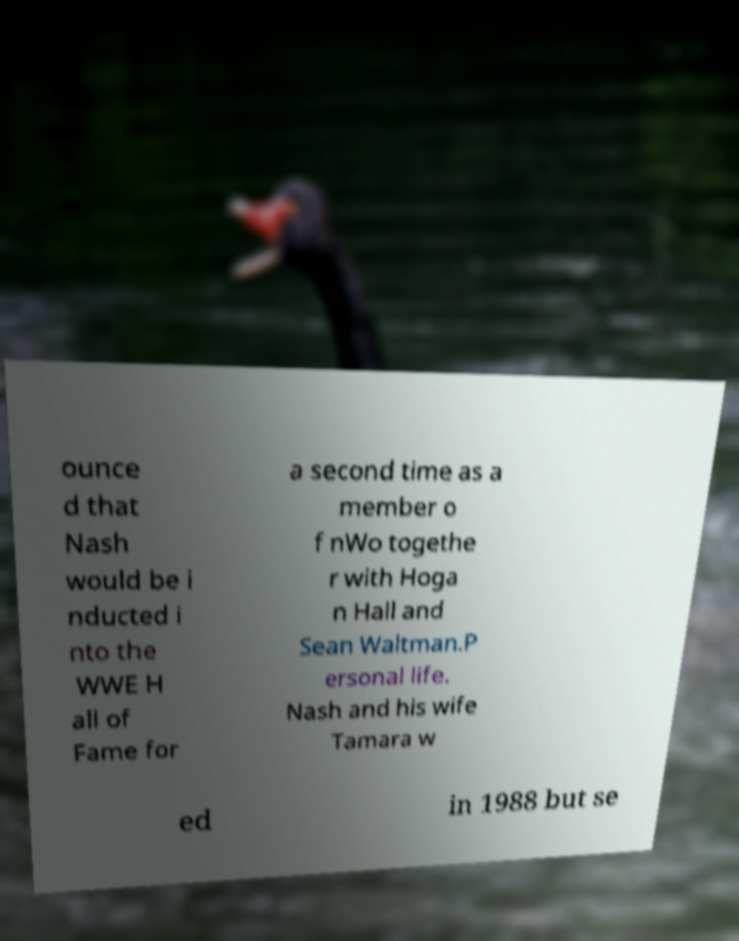Can you read and provide the text displayed in the image?This photo seems to have some interesting text. Can you extract and type it out for me? ounce d that Nash would be i nducted i nto the WWE H all of Fame for a second time as a member o f nWo togethe r with Hoga n Hall and Sean Waltman.P ersonal life. Nash and his wife Tamara w ed in 1988 but se 